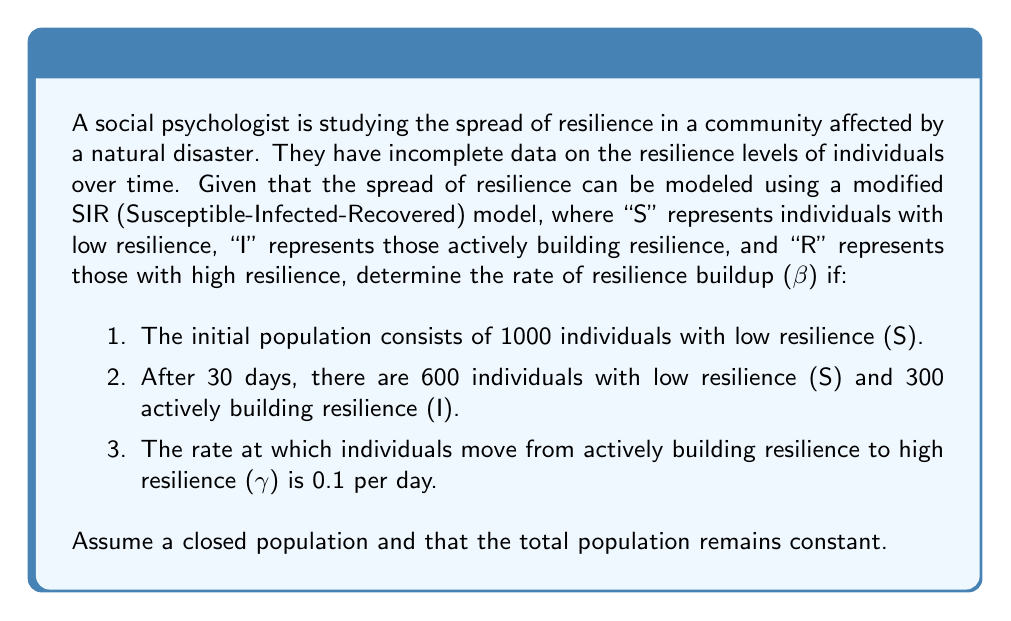Provide a solution to this math problem. To solve this inverse problem and find the rate of resilience buildup ($\beta$), we'll use the SIR model equations and the given information. Let's approach this step-by-step:

1) In the SIR model, the rate of change for the "Susceptible" (S) population is given by:

   $$\frac{dS}{dt} = -\beta SI$$

2) We can approximate this differential equation using the following discrete form:

   $$\frac{S(t) - S(0)}{\Delta t} \approx -\beta \cdot \frac{S(0) + S(t)}{2} \cdot \frac{I(0) + I(t)}{2}$$

3) We know:
   - $S(0) = 1000$ (initial low resilience population)
   - $S(30) = 600$ (low resilience population after 30 days)
   - $I(30) = 300$ (actively building resilience after 30 days)
   - $\Delta t = 30$ days

4) We don't know $I(0)$, but we can estimate it using the fact that the total population remains constant:

   $N = S(0) + I(0) + R(0) = S(30) + I(30) + R(30) = 1000$

   Assuming $R(0) = 0$ (no high resilience individuals initially):
   $I(0) = 1000 - S(0) - R(0) = 1000 - 1000 - 0 = 0$

5) Now we can substitute these values into our discrete approximation:

   $$\frac{600 - 1000}{30} \approx -\beta \cdot \frac{1000 + 600}{2} \cdot \frac{0 + 300}{2}$$

6) Simplifying:

   $$-\frac{400}{30} \approx -\beta \cdot 800 \cdot 150$$

7) Solving for $\beta$:

   $$\beta \approx \frac{400}{30 \cdot 800 \cdot 150} \approx 1.11 \times 10^{-4}$$

Therefore, the rate of resilience buildup ($\beta$) is approximately $1.11 \times 10^{-4}$ per person per day.
Answer: $1.11 \times 10^{-4}$ per person per day 